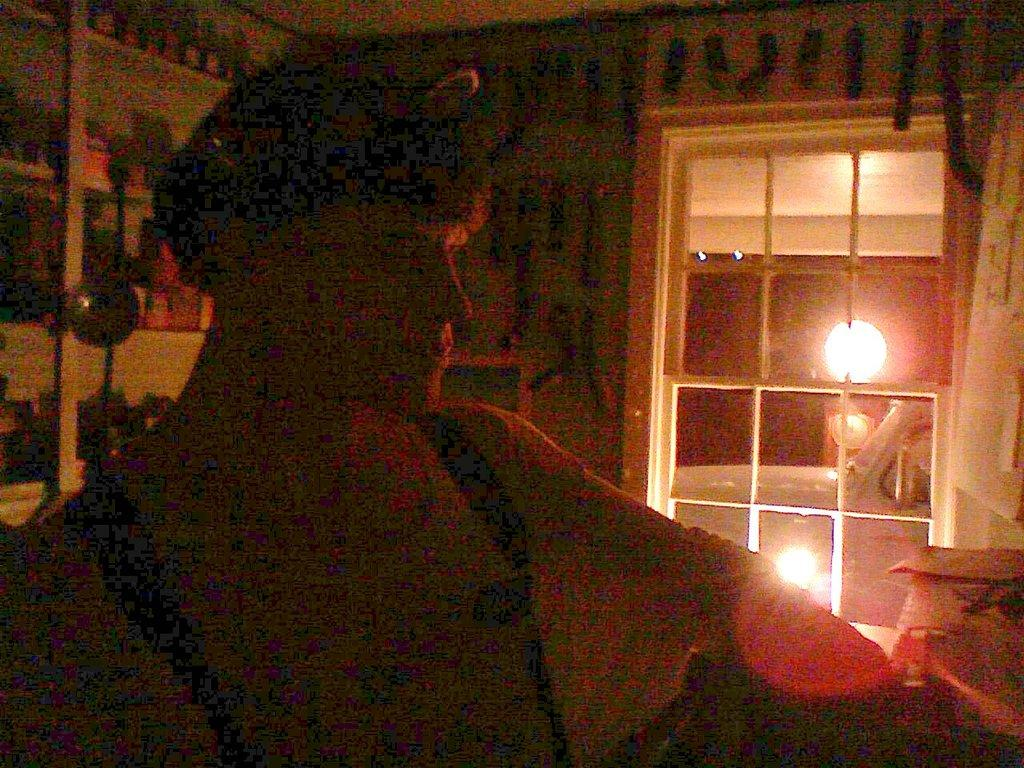Who or what is present in the image? There is a person in the image. What can be seen in the background of the image? There is a wall, lights, and some objects in the background of the image. What type of trees can be seen in the image? There are no trees visible in the image. 